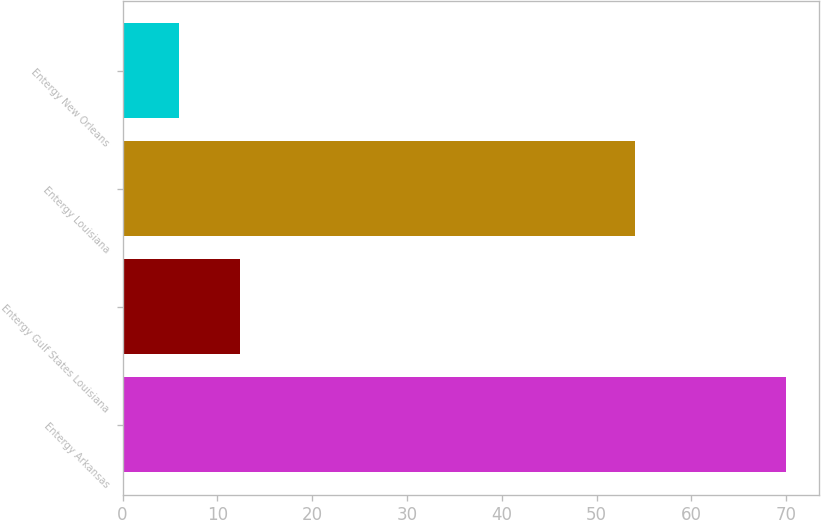Convert chart. <chart><loc_0><loc_0><loc_500><loc_500><bar_chart><fcel>Entergy Arkansas<fcel>Entergy Gulf States Louisiana<fcel>Entergy Louisiana<fcel>Entergy New Orleans<nl><fcel>70<fcel>12.4<fcel>54<fcel>6<nl></chart> 